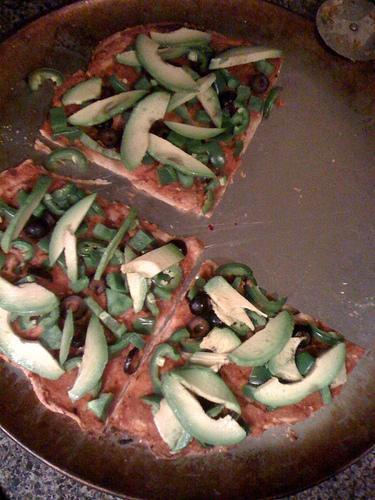What is on the tray?
From the following four choices, select the correct answer to address the question.
Options: Cookie, hand, cake, avocado. Avocado. 